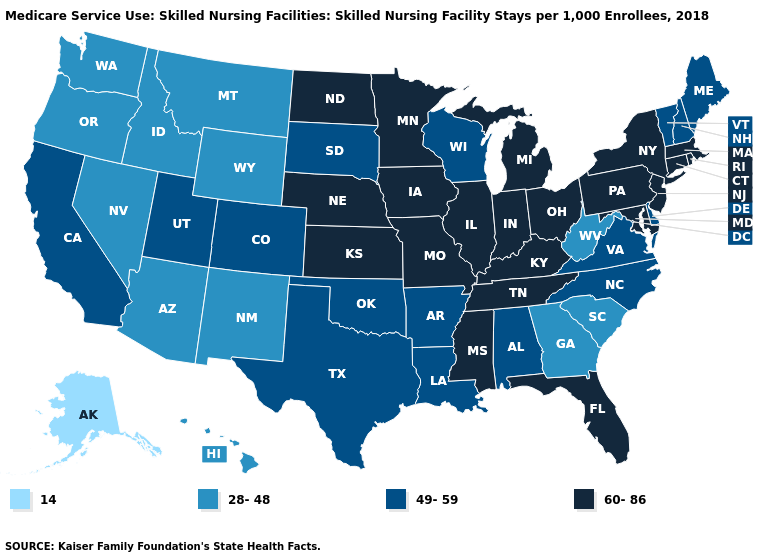Name the states that have a value in the range 49-59?
Quick response, please. Alabama, Arkansas, California, Colorado, Delaware, Louisiana, Maine, New Hampshire, North Carolina, Oklahoma, South Dakota, Texas, Utah, Vermont, Virginia, Wisconsin. Does Colorado have the highest value in the West?
Quick response, please. Yes. Name the states that have a value in the range 49-59?
Answer briefly. Alabama, Arkansas, California, Colorado, Delaware, Louisiana, Maine, New Hampshire, North Carolina, Oklahoma, South Dakota, Texas, Utah, Vermont, Virginia, Wisconsin. Does the first symbol in the legend represent the smallest category?
Be succinct. Yes. Name the states that have a value in the range 14?
Keep it brief. Alaska. What is the value of California?
Give a very brief answer. 49-59. What is the value of Vermont?
Short answer required. 49-59. Among the states that border Mississippi , does Tennessee have the lowest value?
Give a very brief answer. No. Does Rhode Island have the same value as Virginia?
Be succinct. No. Which states have the lowest value in the MidWest?
Be succinct. South Dakota, Wisconsin. What is the value of Tennessee?
Concise answer only. 60-86. What is the lowest value in states that border Pennsylvania?
Short answer required. 28-48. Does Nebraska have a higher value than Rhode Island?
Give a very brief answer. No. What is the value of Iowa?
Answer briefly. 60-86. What is the value of Alabama?
Be succinct. 49-59. 